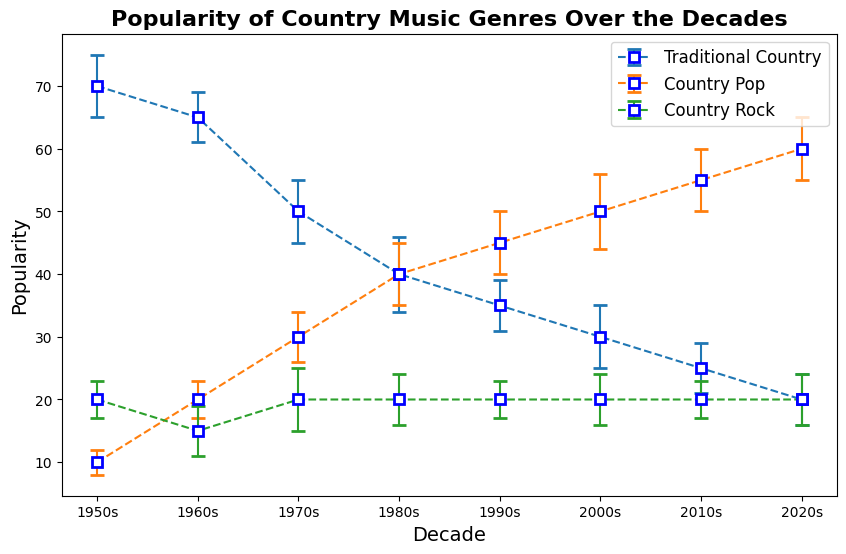What was the most popular country music genre in the 1950s? According to the figure, in the 1950s, Traditional Country had a popularity score of 70, which is higher than Country Pop's 10 and Country Rock's 20.
Answer: Traditional Country Which decade saw the highest popularity of Country Pop? The figure shows that Country Pop reached its highest popularity score of 60 in the 2020s.
Answer: 2020s How did the popularity of Traditional Country change from the 1950s to the 2020s? The figure indicates that the popularity of Traditional Country decreased from 70 in the 1950s to 20 in the 2020s.
Answer: Decreased What is the difference in popularity of Country Rock between the 1990s and 2000s? Both the 1990s and 2000s show Country Rock having a consistent popularity score of 20, so the difference is 0.
Answer: 0 In which decade is the uncertainty (error bar) the largest for Country Pop? Looking at the error bars on the figure, the largest uncertainty for Country Pop is in the 2000s, where the error bar reaches 6.
Answer: 2000s Compare the popularity of Country Rock and Country Pop in the 1960s. In the 1960s, Country Rock had a popularity score of 15, while Country Pop had a score of 20. So, Country Pop was more popular than Country Rock by 5 points.
Answer: Country Pop by 5 points What is the combined popularity of Country Pop and Traditional Country in the 1980s? The popularity scores for Country Pop and Traditional Country in the 1980s are 40 and 40, respectively. Combined, they sum up to 80.
Answer: 80 How did the average popularity of Country Rock change from the 1950s to the 2020s? The popularity of Country Rock remained constant at 20 from the 1950s through the 2020s. Calculating the average for these decades, we get (20+20+20+20+20+20+20+20)/8 = 20.
Answer: No change (remained at 20) Between the 1950s and the 2020s, which genre showed the most considerable reduction in popularity? By comparing the changes, Traditional Country decreased from 70 to 20 (a reduction of 50), Country Pop increased, and Country Rock remained constant. Therefore, Traditional Country had the most considerable reduction.
Answer: Traditional Country 